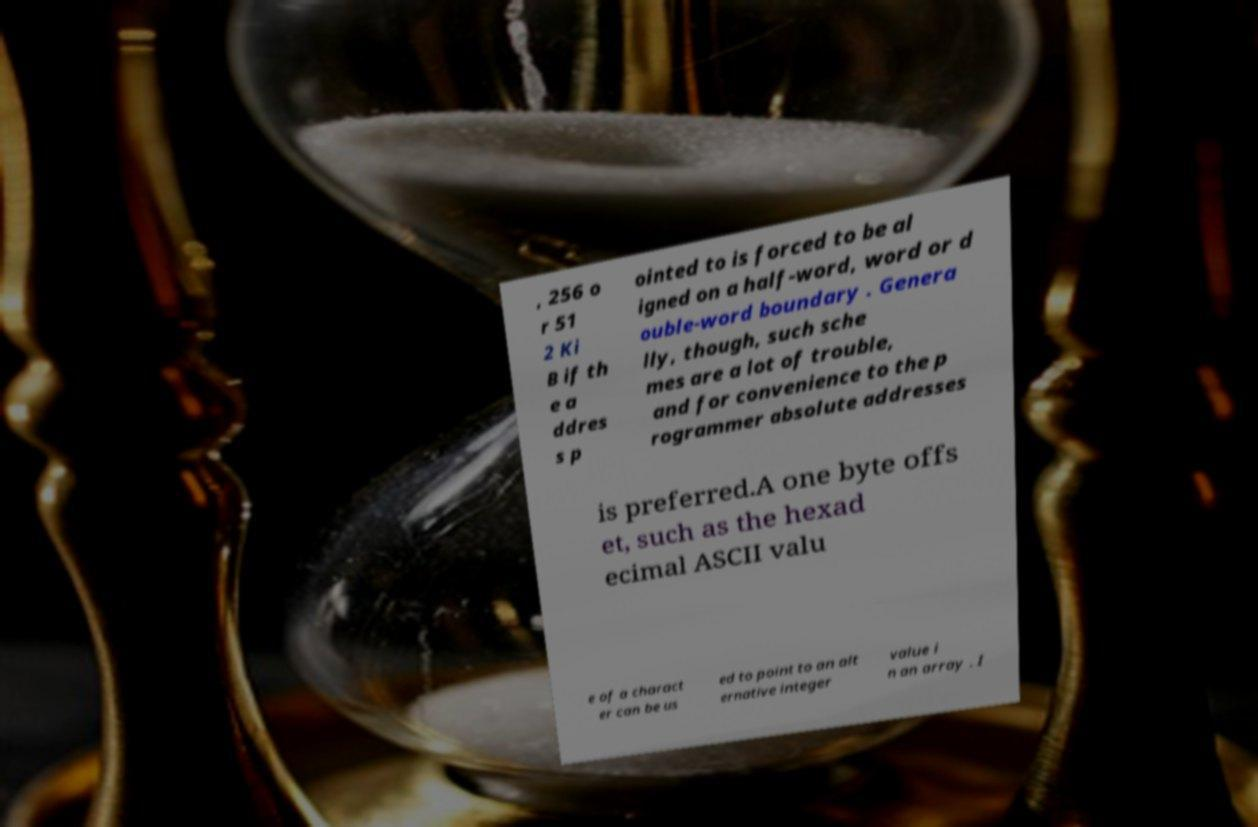Please read and relay the text visible in this image. What does it say? , 256 o r 51 2 Ki B if th e a ddres s p ointed to is forced to be al igned on a half-word, word or d ouble-word boundary . Genera lly, though, such sche mes are a lot of trouble, and for convenience to the p rogrammer absolute addresses is preferred.A one byte offs et, such as the hexad ecimal ASCII valu e of a charact er can be us ed to point to an alt ernative integer value i n an array . I 